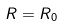Convert formula to latex. <formula><loc_0><loc_0><loc_500><loc_500>R = R _ { 0 }</formula> 